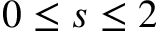<formula> <loc_0><loc_0><loc_500><loc_500>0 \leq s \leq 2</formula> 